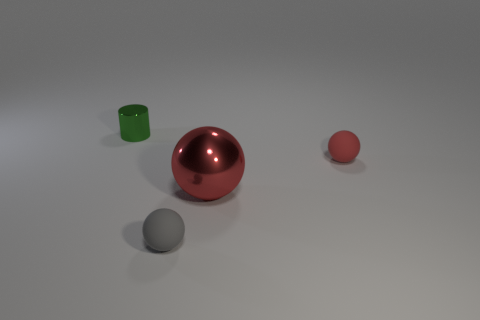Add 3 tiny green metal cylinders. How many objects exist? 7 Subtract all cylinders. How many objects are left? 3 Add 1 tiny green things. How many tiny green things exist? 2 Subtract 0 cyan balls. How many objects are left? 4 Subtract all small gray objects. Subtract all big shiny balls. How many objects are left? 2 Add 3 tiny red spheres. How many tiny red spheres are left? 4 